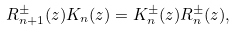<formula> <loc_0><loc_0><loc_500><loc_500>R ^ { \pm } _ { n + 1 } ( z ) K _ { n } ( z ) = K ^ { \pm } _ { n } ( z ) R ^ { \pm } _ { n } ( z ) ,</formula> 